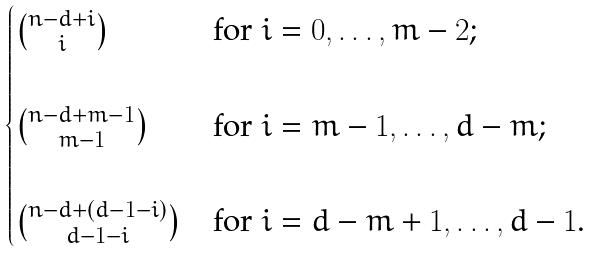Convert formula to latex. <formula><loc_0><loc_0><loc_500><loc_500>\begin{cases} \binom { n - d + i } { i } & \text {for $i=0,\dots,m-2$;} \\ \\ \binom { n - d + m - 1 } { m - 1 } & \text {for $i=m-1,\dots, d-m$;} \\ \\ \binom { n - d + ( d - 1 - i ) } { d - 1 - i } & \text {for $i=d-m+1,\dots,d-1$.} \end{cases}</formula> 